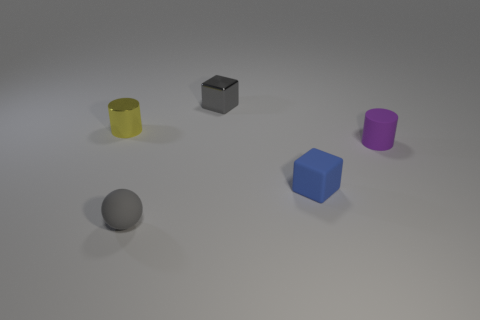Add 1 small metal cylinders. How many objects exist? 6 Subtract all gray cubes. How many cubes are left? 1 Subtract all blocks. How many objects are left? 3 Add 3 metallic blocks. How many metallic blocks exist? 4 Subtract 0 cyan blocks. How many objects are left? 5 Subtract 1 spheres. How many spheres are left? 0 Subtract all purple spheres. Subtract all gray cylinders. How many spheres are left? 1 Subtract all blue blocks. How many green cylinders are left? 0 Subtract all blue matte balls. Subtract all gray metal cubes. How many objects are left? 4 Add 4 small purple objects. How many small purple objects are left? 5 